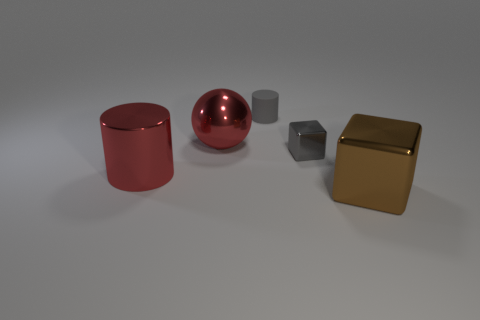Add 2 tiny gray objects. How many objects exist? 7 Subtract all cubes. How many objects are left? 3 Subtract 0 yellow balls. How many objects are left? 5 Subtract all small gray rubber cylinders. Subtract all small yellow matte cylinders. How many objects are left? 4 Add 4 small rubber objects. How many small rubber objects are left? 5 Add 4 big red metal cylinders. How many big red metal cylinders exist? 5 